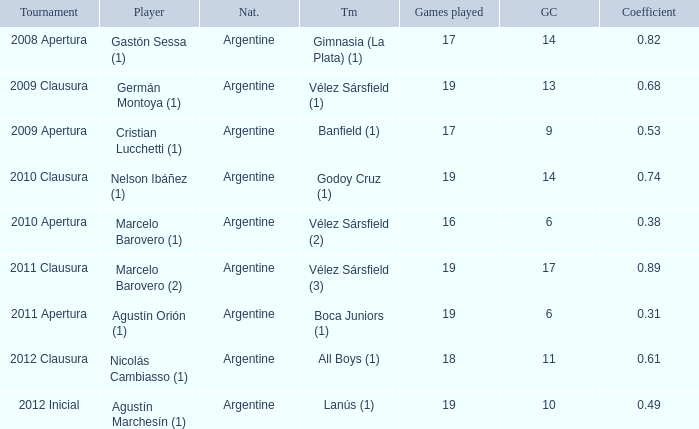Could you help me parse every detail presented in this table? {'header': ['Tournament', 'Player', 'Nat.', 'Tm', 'Games played', 'GC', 'Coefficient'], 'rows': [['2008 Apertura', 'Gastón Sessa (1)', 'Argentine', 'Gimnasia (La Plata) (1)', '17', '14', '0.82'], ['2009 Clausura', 'Germán Montoya (1)', 'Argentine', 'Vélez Sársfield (1)', '19', '13', '0.68'], ['2009 Apertura', 'Cristian Lucchetti (1)', 'Argentine', 'Banfield (1)', '17', '9', '0.53'], ['2010 Clausura', 'Nelson Ibáñez (1)', 'Argentine', 'Godoy Cruz (1)', '19', '14', '0.74'], ['2010 Apertura', 'Marcelo Barovero (1)', 'Argentine', 'Vélez Sársfield (2)', '16', '6', '0.38'], ['2011 Clausura', 'Marcelo Barovero (2)', 'Argentine', 'Vélez Sársfield (3)', '19', '17', '0.89'], ['2011 Apertura', 'Agustín Orión (1)', 'Argentine', 'Boca Juniors (1)', '19', '6', '0.31'], ['2012 Clausura', 'Nicolás Cambiasso (1)', 'Argentine', 'All Boys (1)', '18', '11', '0.61'], ['2012 Inicial', 'Agustín Marchesín (1)', 'Argentine', 'Lanús (1)', '19', '10', '0.49']]}  the 2010 clausura tournament? 0.74. 